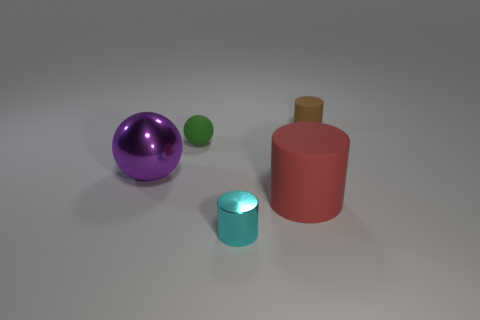Is the color of the tiny metal cylinder the same as the metallic thing that is left of the small green ball?
Offer a very short reply. No. The rubber object that is to the left of the rubber thing that is in front of the large metallic sphere to the left of the small brown rubber thing is what color?
Provide a succinct answer. Green. Are there any tiny red matte things that have the same shape as the big red matte thing?
Your answer should be very brief. No. What color is the shiny cylinder that is the same size as the brown rubber cylinder?
Your answer should be compact. Cyan. There is a tiny object in front of the large red rubber thing; what is it made of?
Your response must be concise. Metal. Is the shape of the rubber thing on the left side of the cyan shiny cylinder the same as the tiny thing on the right side of the big red rubber thing?
Provide a short and direct response. No. Are there the same number of purple objects that are on the left side of the purple ball and purple things?
Provide a succinct answer. No. What number of other objects have the same material as the small brown object?
Make the answer very short. 2. What color is the small sphere that is the same material as the red thing?
Your response must be concise. Green. Is the size of the purple shiny ball the same as the sphere that is on the right side of the purple object?
Offer a terse response. No. 